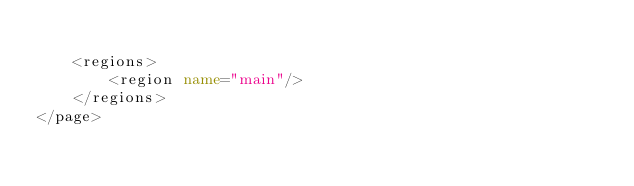Convert code to text. <code><loc_0><loc_0><loc_500><loc_500><_XML_>
    <regions>
        <region name="main"/>
    </regions>
</page>
</code> 